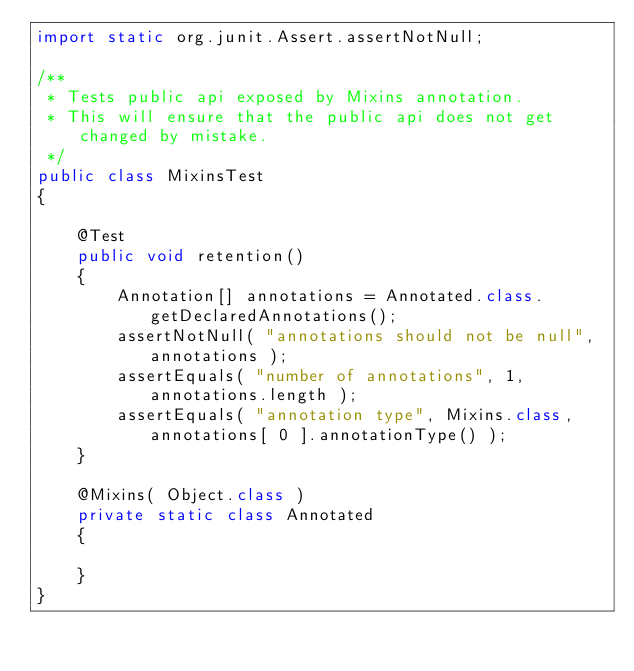<code> <loc_0><loc_0><loc_500><loc_500><_Java_>import static org.junit.Assert.assertNotNull;

/**
 * Tests public api exposed by Mixins annotation.
 * This will ensure that the public api does not get changed by mistake.
 */
public class MixinsTest
{

    @Test
    public void retention()
    {
        Annotation[] annotations = Annotated.class.getDeclaredAnnotations();
        assertNotNull( "annotations should not be null", annotations );
        assertEquals( "number of annotations", 1, annotations.length );
        assertEquals( "annotation type", Mixins.class, annotations[ 0 ].annotationType() );
    }

    @Mixins( Object.class )
    private static class Annotated
    {

    }
}
</code> 